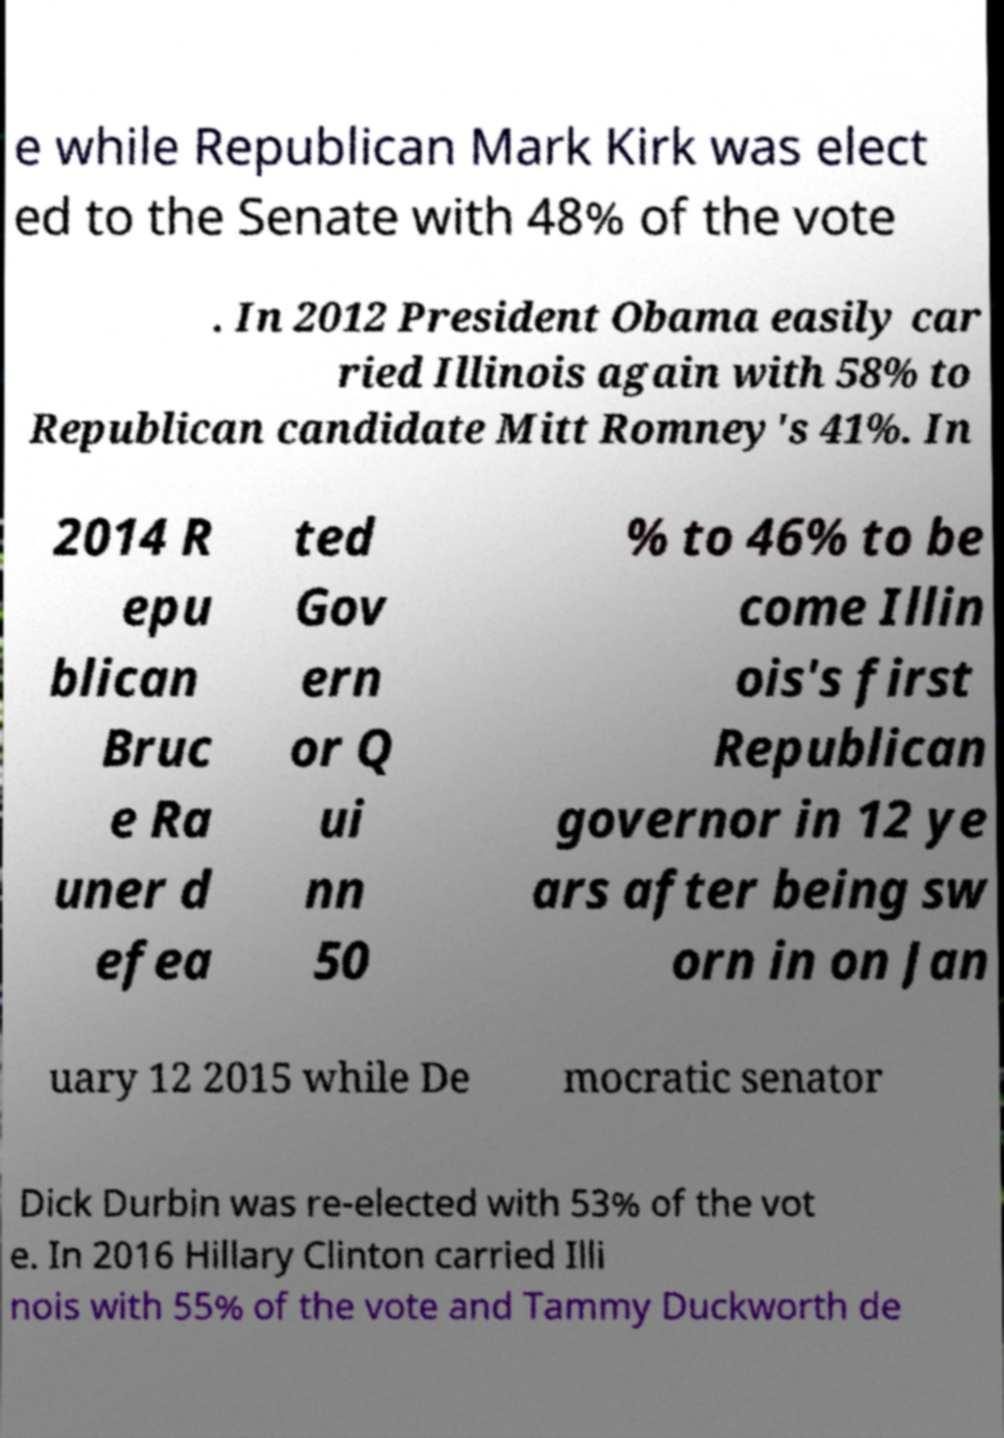Can you read and provide the text displayed in the image?This photo seems to have some interesting text. Can you extract and type it out for me? e while Republican Mark Kirk was elect ed to the Senate with 48% of the vote . In 2012 President Obama easily car ried Illinois again with 58% to Republican candidate Mitt Romney's 41%. In 2014 R epu blican Bruc e Ra uner d efea ted Gov ern or Q ui nn 50 % to 46% to be come Illin ois's first Republican governor in 12 ye ars after being sw orn in on Jan uary 12 2015 while De mocratic senator Dick Durbin was re-elected with 53% of the vot e. In 2016 Hillary Clinton carried Illi nois with 55% of the vote and Tammy Duckworth de 